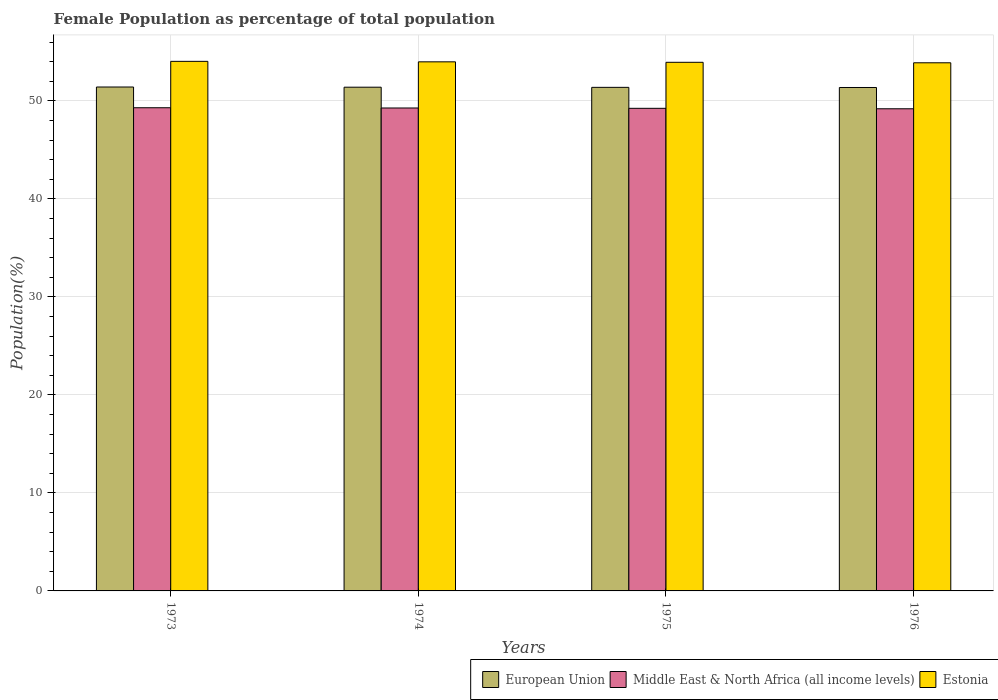How many different coloured bars are there?
Your response must be concise. 3. How many groups of bars are there?
Provide a succinct answer. 4. Are the number of bars per tick equal to the number of legend labels?
Provide a short and direct response. Yes. How many bars are there on the 2nd tick from the left?
Your answer should be compact. 3. What is the label of the 3rd group of bars from the left?
Offer a very short reply. 1975. What is the female population in in Estonia in 1976?
Give a very brief answer. 53.89. Across all years, what is the maximum female population in in Middle East & North Africa (all income levels)?
Give a very brief answer. 49.31. Across all years, what is the minimum female population in in European Union?
Keep it short and to the point. 51.37. In which year was the female population in in European Union maximum?
Give a very brief answer. 1973. In which year was the female population in in Estonia minimum?
Provide a short and direct response. 1976. What is the total female population in in Estonia in the graph?
Provide a succinct answer. 215.86. What is the difference between the female population in in European Union in 1973 and that in 1976?
Your response must be concise. 0.05. What is the difference between the female population in in Middle East & North Africa (all income levels) in 1975 and the female population in in Estonia in 1976?
Give a very brief answer. -4.65. What is the average female population in in European Union per year?
Offer a very short reply. 51.4. In the year 1973, what is the difference between the female population in in European Union and female population in in Middle East & North Africa (all income levels)?
Offer a terse response. 2.12. What is the ratio of the female population in in Estonia in 1974 to that in 1976?
Provide a succinct answer. 1. Is the difference between the female population in in European Union in 1973 and 1974 greater than the difference between the female population in in Middle East & North Africa (all income levels) in 1973 and 1974?
Your response must be concise. No. What is the difference between the highest and the second highest female population in in European Union?
Your answer should be compact. 0.02. What is the difference between the highest and the lowest female population in in Middle East & North Africa (all income levels)?
Your answer should be compact. 0.11. In how many years, is the female population in in Estonia greater than the average female population in in Estonia taken over all years?
Provide a succinct answer. 2. What does the 1st bar from the left in 1976 represents?
Offer a very short reply. European Union. What does the 2nd bar from the right in 1975 represents?
Your answer should be compact. Middle East & North Africa (all income levels). Is it the case that in every year, the sum of the female population in in European Union and female population in in Estonia is greater than the female population in in Middle East & North Africa (all income levels)?
Provide a succinct answer. Yes. Are all the bars in the graph horizontal?
Your answer should be compact. No. How many years are there in the graph?
Provide a succinct answer. 4. Are the values on the major ticks of Y-axis written in scientific E-notation?
Keep it short and to the point. No. Does the graph contain grids?
Ensure brevity in your answer.  Yes. What is the title of the graph?
Ensure brevity in your answer.  Female Population as percentage of total population. What is the label or title of the X-axis?
Your answer should be compact. Years. What is the label or title of the Y-axis?
Provide a short and direct response. Population(%). What is the Population(%) of European Union in 1973?
Your answer should be compact. 51.42. What is the Population(%) in Middle East & North Africa (all income levels) in 1973?
Provide a short and direct response. 49.31. What is the Population(%) of Estonia in 1973?
Your answer should be very brief. 54.04. What is the Population(%) of European Union in 1974?
Ensure brevity in your answer.  51.4. What is the Population(%) of Middle East & North Africa (all income levels) in 1974?
Provide a succinct answer. 49.28. What is the Population(%) of Estonia in 1974?
Your response must be concise. 53.99. What is the Population(%) of European Union in 1975?
Offer a terse response. 51.39. What is the Population(%) in Middle East & North Africa (all income levels) in 1975?
Give a very brief answer. 49.25. What is the Population(%) in Estonia in 1975?
Ensure brevity in your answer.  53.94. What is the Population(%) of European Union in 1976?
Offer a terse response. 51.37. What is the Population(%) in Middle East & North Africa (all income levels) in 1976?
Give a very brief answer. 49.2. What is the Population(%) of Estonia in 1976?
Your answer should be compact. 53.89. Across all years, what is the maximum Population(%) of European Union?
Keep it short and to the point. 51.42. Across all years, what is the maximum Population(%) of Middle East & North Africa (all income levels)?
Make the answer very short. 49.31. Across all years, what is the maximum Population(%) in Estonia?
Make the answer very short. 54.04. Across all years, what is the minimum Population(%) of European Union?
Ensure brevity in your answer.  51.37. Across all years, what is the minimum Population(%) in Middle East & North Africa (all income levels)?
Provide a succinct answer. 49.2. Across all years, what is the minimum Population(%) in Estonia?
Your answer should be compact. 53.89. What is the total Population(%) in European Union in the graph?
Provide a succinct answer. 205.58. What is the total Population(%) of Middle East & North Africa (all income levels) in the graph?
Your answer should be very brief. 197.03. What is the total Population(%) in Estonia in the graph?
Give a very brief answer. 215.86. What is the difference between the Population(%) of European Union in 1973 and that in 1974?
Your answer should be very brief. 0.02. What is the difference between the Population(%) of Middle East & North Africa (all income levels) in 1973 and that in 1974?
Your response must be concise. 0.02. What is the difference between the Population(%) of Estonia in 1973 and that in 1974?
Provide a succinct answer. 0.05. What is the difference between the Population(%) of European Union in 1973 and that in 1975?
Ensure brevity in your answer.  0.04. What is the difference between the Population(%) in Middle East & North Africa (all income levels) in 1973 and that in 1975?
Your answer should be compact. 0.06. What is the difference between the Population(%) in Estonia in 1973 and that in 1975?
Your answer should be compact. 0.1. What is the difference between the Population(%) in European Union in 1973 and that in 1976?
Give a very brief answer. 0.05. What is the difference between the Population(%) of Middle East & North Africa (all income levels) in 1973 and that in 1976?
Provide a short and direct response. 0.11. What is the difference between the Population(%) in Estonia in 1973 and that in 1976?
Ensure brevity in your answer.  0.15. What is the difference between the Population(%) in European Union in 1974 and that in 1975?
Offer a terse response. 0.02. What is the difference between the Population(%) of Middle East & North Africa (all income levels) in 1974 and that in 1975?
Your answer should be very brief. 0.03. What is the difference between the Population(%) of Estonia in 1974 and that in 1975?
Provide a short and direct response. 0.05. What is the difference between the Population(%) in European Union in 1974 and that in 1976?
Your answer should be compact. 0.03. What is the difference between the Population(%) of Middle East & North Africa (all income levels) in 1974 and that in 1976?
Provide a short and direct response. 0.08. What is the difference between the Population(%) of Estonia in 1974 and that in 1976?
Your response must be concise. 0.1. What is the difference between the Population(%) of European Union in 1975 and that in 1976?
Offer a very short reply. 0.01. What is the difference between the Population(%) of Middle East & North Africa (all income levels) in 1975 and that in 1976?
Your response must be concise. 0.05. What is the difference between the Population(%) of Estonia in 1975 and that in 1976?
Provide a succinct answer. 0.05. What is the difference between the Population(%) in European Union in 1973 and the Population(%) in Middle East & North Africa (all income levels) in 1974?
Give a very brief answer. 2.14. What is the difference between the Population(%) of European Union in 1973 and the Population(%) of Estonia in 1974?
Make the answer very short. -2.57. What is the difference between the Population(%) in Middle East & North Africa (all income levels) in 1973 and the Population(%) in Estonia in 1974?
Offer a terse response. -4.68. What is the difference between the Population(%) in European Union in 1973 and the Population(%) in Middle East & North Africa (all income levels) in 1975?
Your answer should be compact. 2.17. What is the difference between the Population(%) in European Union in 1973 and the Population(%) in Estonia in 1975?
Your response must be concise. -2.52. What is the difference between the Population(%) of Middle East & North Africa (all income levels) in 1973 and the Population(%) of Estonia in 1975?
Your response must be concise. -4.64. What is the difference between the Population(%) of European Union in 1973 and the Population(%) of Middle East & North Africa (all income levels) in 1976?
Give a very brief answer. 2.22. What is the difference between the Population(%) of European Union in 1973 and the Population(%) of Estonia in 1976?
Your answer should be compact. -2.47. What is the difference between the Population(%) of Middle East & North Africa (all income levels) in 1973 and the Population(%) of Estonia in 1976?
Provide a succinct answer. -4.59. What is the difference between the Population(%) of European Union in 1974 and the Population(%) of Middle East & North Africa (all income levels) in 1975?
Provide a succinct answer. 2.16. What is the difference between the Population(%) in European Union in 1974 and the Population(%) in Estonia in 1975?
Your answer should be very brief. -2.54. What is the difference between the Population(%) of Middle East & North Africa (all income levels) in 1974 and the Population(%) of Estonia in 1975?
Provide a short and direct response. -4.66. What is the difference between the Population(%) of European Union in 1974 and the Population(%) of Middle East & North Africa (all income levels) in 1976?
Your response must be concise. 2.2. What is the difference between the Population(%) of European Union in 1974 and the Population(%) of Estonia in 1976?
Provide a succinct answer. -2.49. What is the difference between the Population(%) of Middle East & North Africa (all income levels) in 1974 and the Population(%) of Estonia in 1976?
Offer a very short reply. -4.61. What is the difference between the Population(%) of European Union in 1975 and the Population(%) of Middle East & North Africa (all income levels) in 1976?
Your answer should be compact. 2.19. What is the difference between the Population(%) of European Union in 1975 and the Population(%) of Estonia in 1976?
Offer a very short reply. -2.51. What is the difference between the Population(%) of Middle East & North Africa (all income levels) in 1975 and the Population(%) of Estonia in 1976?
Ensure brevity in your answer.  -4.65. What is the average Population(%) in European Union per year?
Ensure brevity in your answer.  51.4. What is the average Population(%) of Middle East & North Africa (all income levels) per year?
Your answer should be very brief. 49.26. What is the average Population(%) in Estonia per year?
Ensure brevity in your answer.  53.97. In the year 1973, what is the difference between the Population(%) of European Union and Population(%) of Middle East & North Africa (all income levels)?
Your response must be concise. 2.12. In the year 1973, what is the difference between the Population(%) of European Union and Population(%) of Estonia?
Keep it short and to the point. -2.62. In the year 1973, what is the difference between the Population(%) of Middle East & North Africa (all income levels) and Population(%) of Estonia?
Ensure brevity in your answer.  -4.73. In the year 1974, what is the difference between the Population(%) of European Union and Population(%) of Middle East & North Africa (all income levels)?
Give a very brief answer. 2.12. In the year 1974, what is the difference between the Population(%) in European Union and Population(%) in Estonia?
Keep it short and to the point. -2.59. In the year 1974, what is the difference between the Population(%) in Middle East & North Africa (all income levels) and Population(%) in Estonia?
Provide a short and direct response. -4.71. In the year 1975, what is the difference between the Population(%) in European Union and Population(%) in Middle East & North Africa (all income levels)?
Offer a very short reply. 2.14. In the year 1975, what is the difference between the Population(%) in European Union and Population(%) in Estonia?
Keep it short and to the point. -2.56. In the year 1975, what is the difference between the Population(%) in Middle East & North Africa (all income levels) and Population(%) in Estonia?
Your response must be concise. -4.7. In the year 1976, what is the difference between the Population(%) in European Union and Population(%) in Middle East & North Africa (all income levels)?
Give a very brief answer. 2.17. In the year 1976, what is the difference between the Population(%) of European Union and Population(%) of Estonia?
Offer a very short reply. -2.52. In the year 1976, what is the difference between the Population(%) of Middle East & North Africa (all income levels) and Population(%) of Estonia?
Give a very brief answer. -4.69. What is the ratio of the Population(%) of European Union in 1973 to that in 1974?
Offer a terse response. 1. What is the ratio of the Population(%) of Estonia in 1973 to that in 1974?
Your answer should be very brief. 1. What is the ratio of the Population(%) of European Union in 1973 to that in 1975?
Your answer should be compact. 1. What is the ratio of the Population(%) in Middle East & North Africa (all income levels) in 1973 to that in 1975?
Your answer should be very brief. 1. What is the ratio of the Population(%) in Estonia in 1973 to that in 1975?
Give a very brief answer. 1. What is the ratio of the Population(%) in European Union in 1973 to that in 1976?
Make the answer very short. 1. What is the ratio of the Population(%) of Middle East & North Africa (all income levels) in 1973 to that in 1976?
Your answer should be very brief. 1. What is the ratio of the Population(%) in European Union in 1974 to that in 1975?
Your answer should be compact. 1. What is the ratio of the Population(%) of Middle East & North Africa (all income levels) in 1974 to that in 1975?
Your response must be concise. 1. What is the ratio of the Population(%) in Middle East & North Africa (all income levels) in 1974 to that in 1976?
Offer a terse response. 1. What is the ratio of the Population(%) in Middle East & North Africa (all income levels) in 1975 to that in 1976?
Offer a very short reply. 1. What is the difference between the highest and the second highest Population(%) of European Union?
Keep it short and to the point. 0.02. What is the difference between the highest and the second highest Population(%) in Middle East & North Africa (all income levels)?
Provide a short and direct response. 0.02. What is the difference between the highest and the second highest Population(%) in Estonia?
Offer a terse response. 0.05. What is the difference between the highest and the lowest Population(%) in European Union?
Your answer should be compact. 0.05. What is the difference between the highest and the lowest Population(%) in Middle East & North Africa (all income levels)?
Give a very brief answer. 0.11. What is the difference between the highest and the lowest Population(%) in Estonia?
Your answer should be very brief. 0.15. 